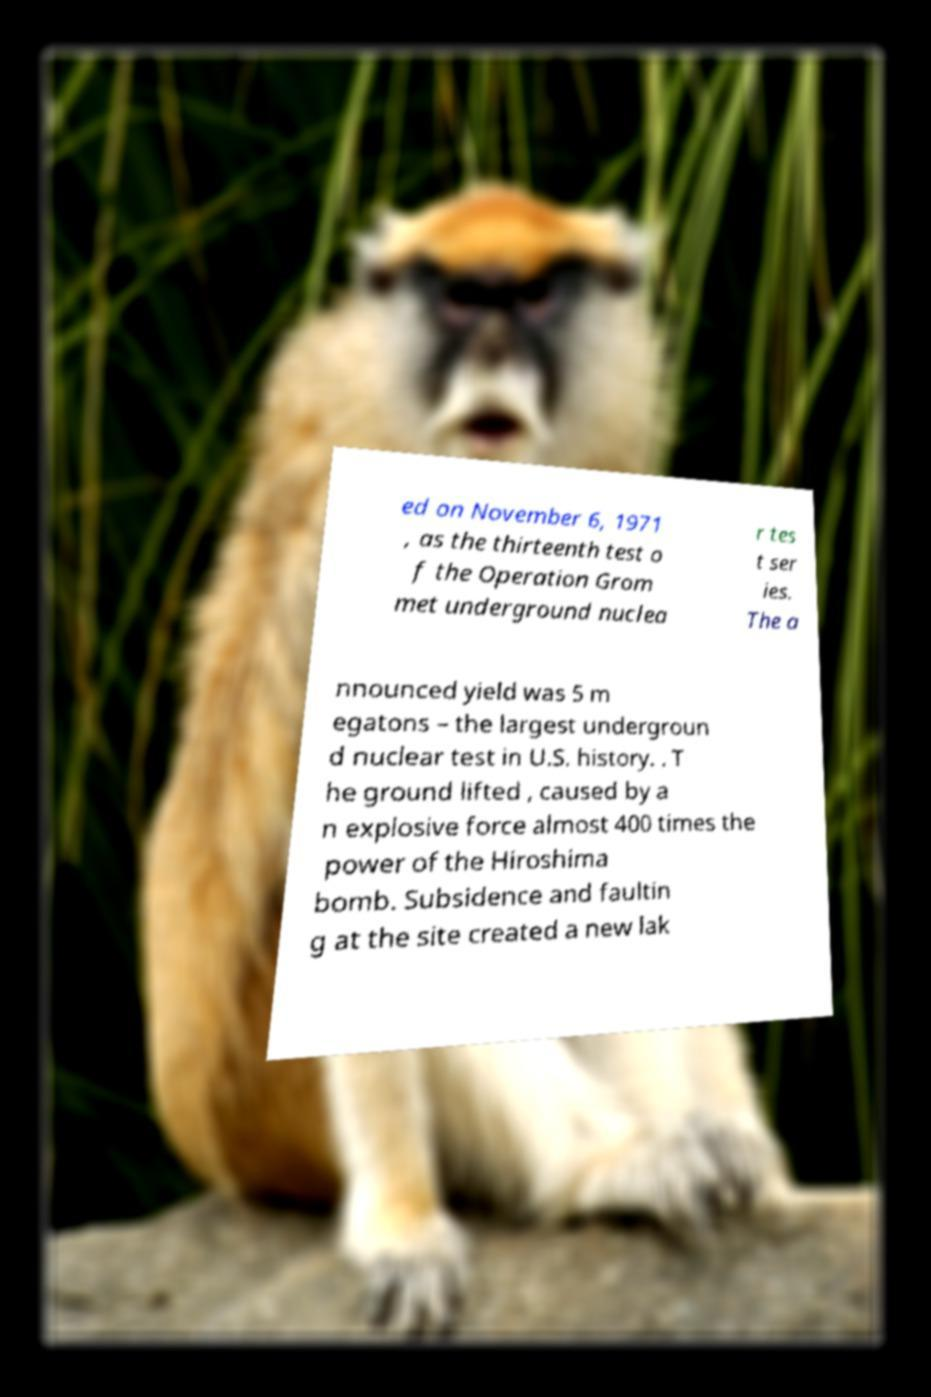Could you assist in decoding the text presented in this image and type it out clearly? ed on November 6, 1971 , as the thirteenth test o f the Operation Grom met underground nuclea r tes t ser ies. The a nnounced yield was 5 m egatons – the largest undergroun d nuclear test in U.S. history. . T he ground lifted , caused by a n explosive force almost 400 times the power of the Hiroshima bomb. Subsidence and faultin g at the site created a new lak 